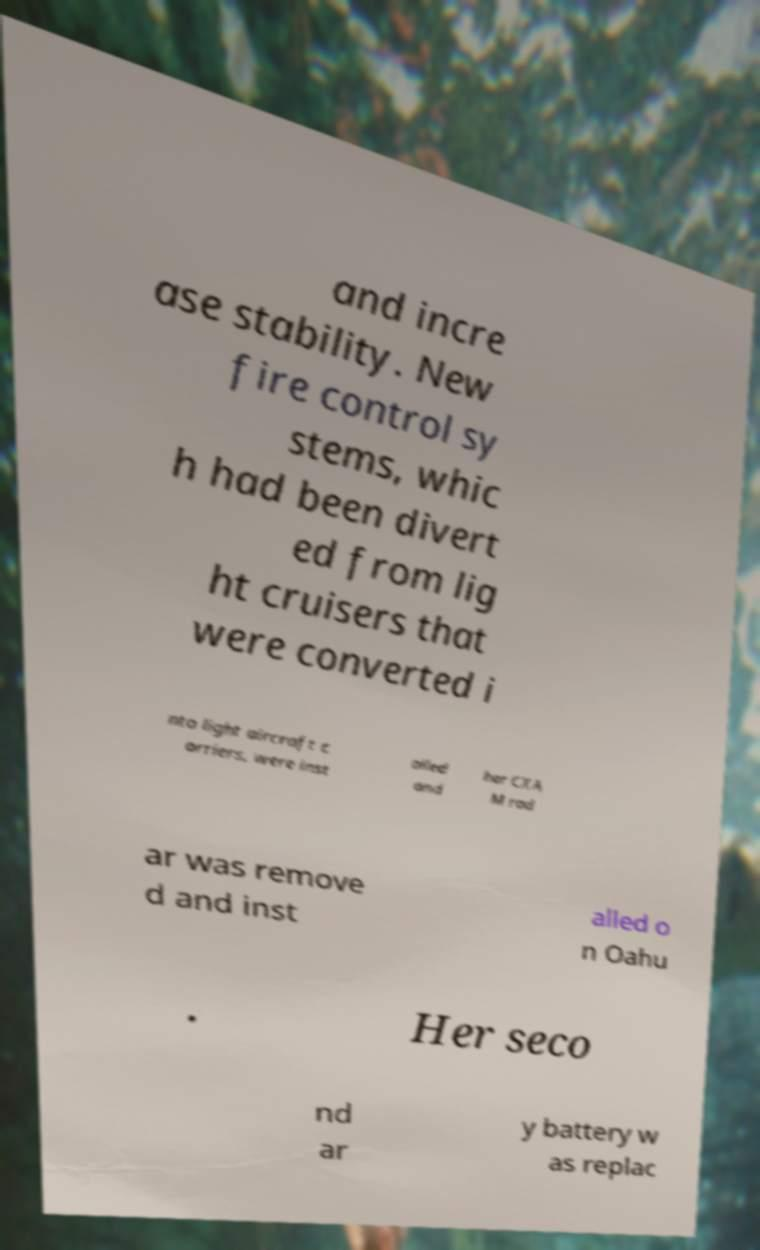I need the written content from this picture converted into text. Can you do that? and incre ase stability. New fire control sy stems, whic h had been divert ed from lig ht cruisers that were converted i nto light aircraft c arriers, were inst alled and her CXA M rad ar was remove d and inst alled o n Oahu . Her seco nd ar y battery w as replac 